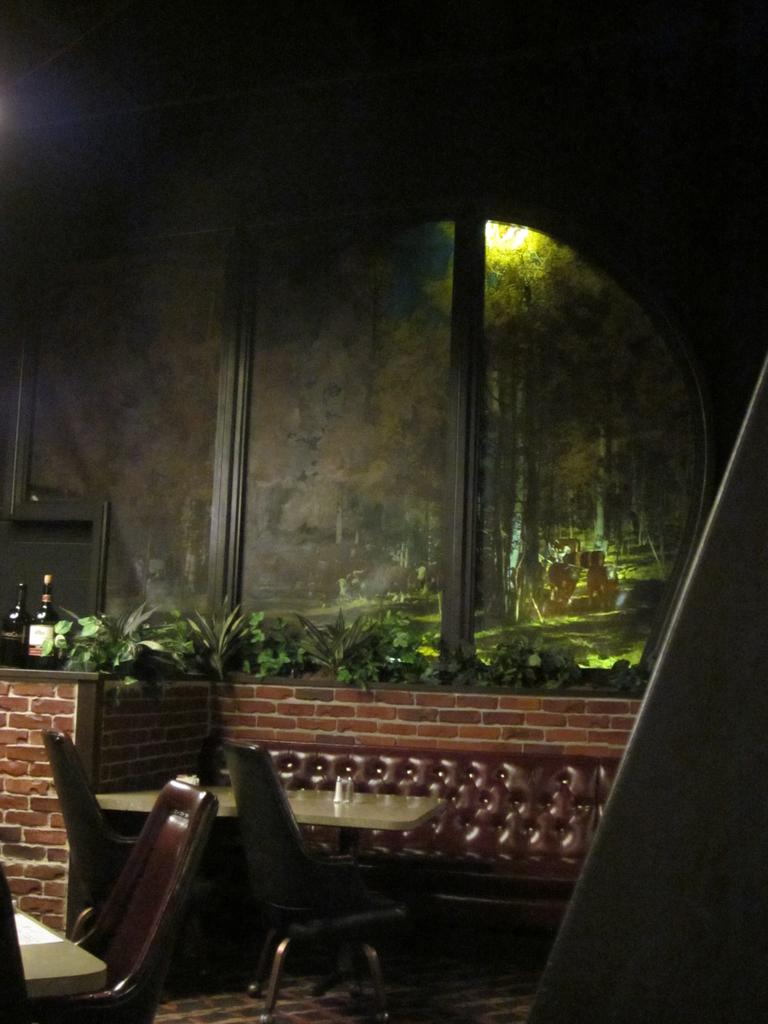What is one of the objects in the image that can reflect images? There is a mirror in the image that can reflect images. What type of items can be seen that people might use to drink from? There are beverage bottles in the image that people might use to drink from. What type of furniture is present in the image that people can sit on? There are chairs and a sofa set in the image that people can sit on. What type of furniture is present in the image that people can place items on? There are tables in the image that people can place items on. What type of living organisms can be seen in the image? There are plants in the image. What type of surface is visible in the image? There is a floor visible in the image. What type of cough can be heard in the image? There is no sound, including coughing, present in the image. What type of marble is visible in the image? There is no marble present in the image. 